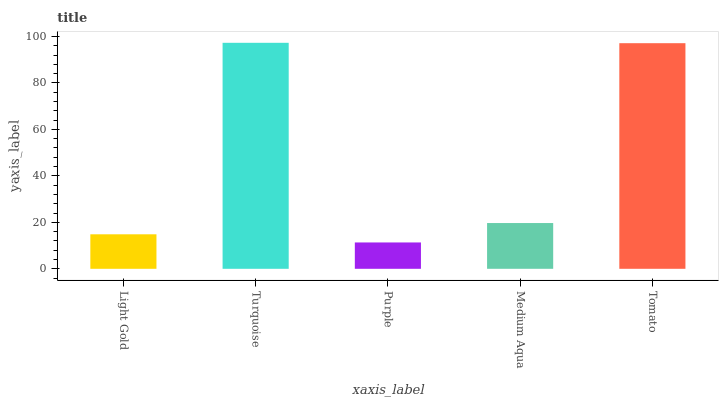Is Purple the minimum?
Answer yes or no. Yes. Is Turquoise the maximum?
Answer yes or no. Yes. Is Turquoise the minimum?
Answer yes or no. No. Is Purple the maximum?
Answer yes or no. No. Is Turquoise greater than Purple?
Answer yes or no. Yes. Is Purple less than Turquoise?
Answer yes or no. Yes. Is Purple greater than Turquoise?
Answer yes or no. No. Is Turquoise less than Purple?
Answer yes or no. No. Is Medium Aqua the high median?
Answer yes or no. Yes. Is Medium Aqua the low median?
Answer yes or no. Yes. Is Tomato the high median?
Answer yes or no. No. Is Light Gold the low median?
Answer yes or no. No. 